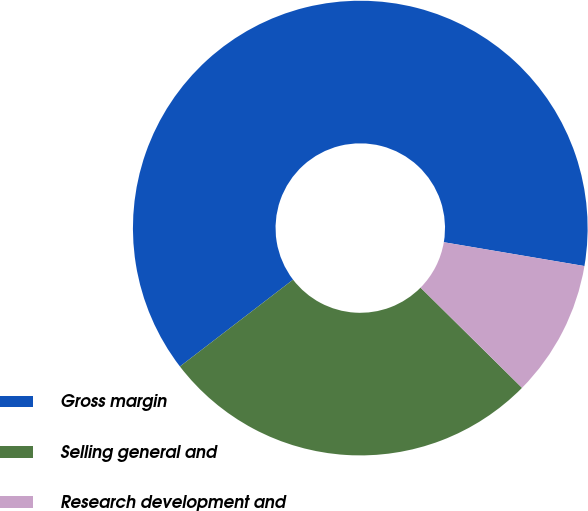Convert chart. <chart><loc_0><loc_0><loc_500><loc_500><pie_chart><fcel>Gross margin<fcel>Selling general and<fcel>Research development and<nl><fcel>63.09%<fcel>27.18%<fcel>9.73%<nl></chart> 